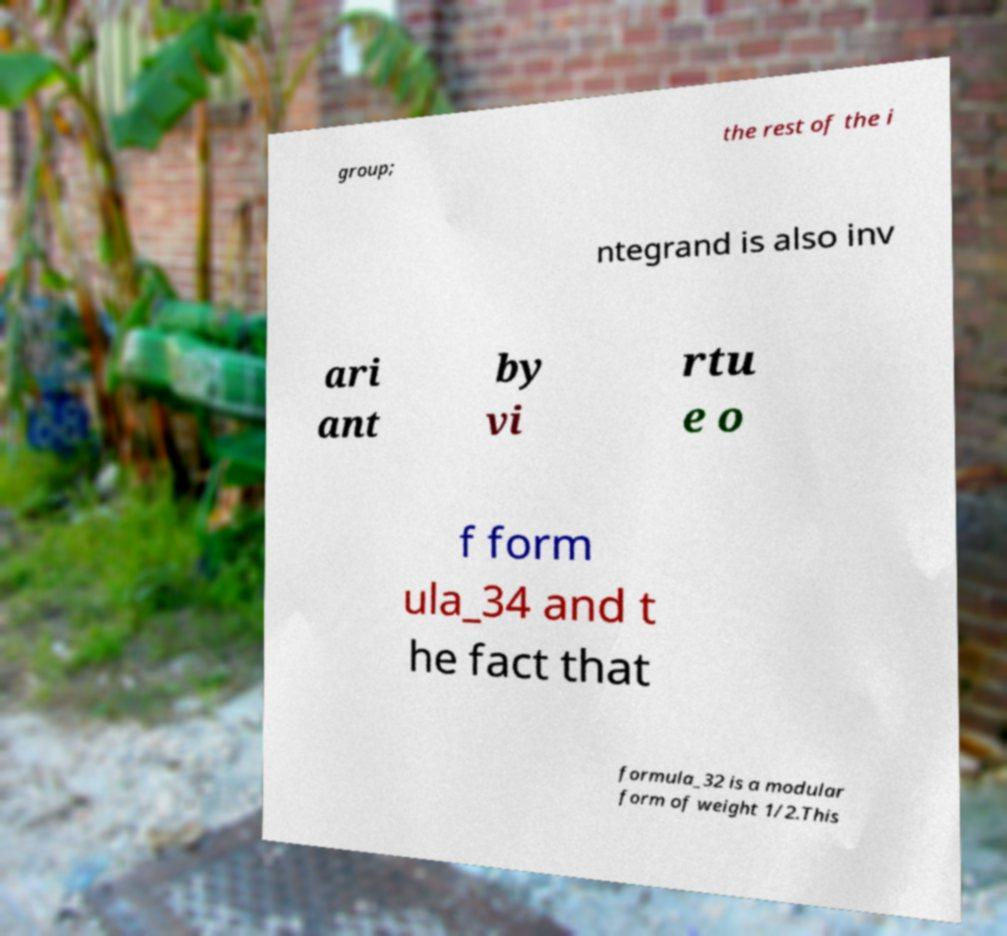Could you extract and type out the text from this image? group; the rest of the i ntegrand is also inv ari ant by vi rtu e o f form ula_34 and t he fact that formula_32 is a modular form of weight 1/2.This 